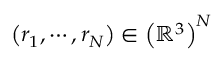<formula> <loc_0><loc_0><loc_500><loc_500>\left ( r _ { 1 } , \cdots , r _ { N } \right ) \in \left ( \mathbb { R } ^ { 3 } \right ) ^ { N }</formula> 